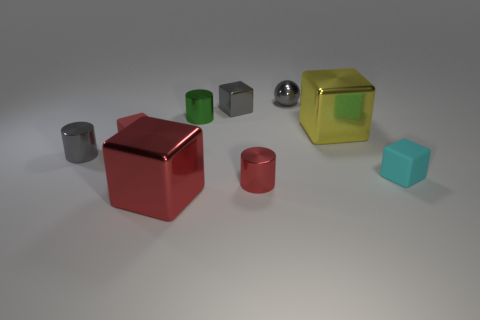Is there any other thing that has the same size as the cyan rubber object?
Your answer should be compact. Yes. What material is the tiny red thing to the left of the small thing in front of the small cyan rubber cube?
Your answer should be compact. Rubber. Does the green metallic object have the same shape as the tiny cyan matte thing?
Your answer should be very brief. No. What number of tiny cubes are in front of the gray block and right of the tiny red cube?
Your answer should be compact. 1. Is the number of small gray shiny cylinders in front of the large red shiny cube the same as the number of small cyan rubber things that are behind the cyan object?
Provide a succinct answer. Yes. There is a gray shiny object that is right of the tiny gray cube; is it the same size as the metal cylinder that is in front of the cyan cube?
Offer a very short reply. Yes. What is the block that is behind the small cyan object and on the right side of the small red cylinder made of?
Offer a terse response. Metal. Are there fewer tiny rubber things than gray metallic balls?
Provide a short and direct response. No. How big is the cyan matte cube that is to the right of the small red object on the left side of the green metallic object?
Offer a terse response. Small. There is a big metallic thing that is behind the metallic cylinder that is right of the tiny cylinder that is behind the red rubber object; what shape is it?
Your answer should be very brief. Cube. 